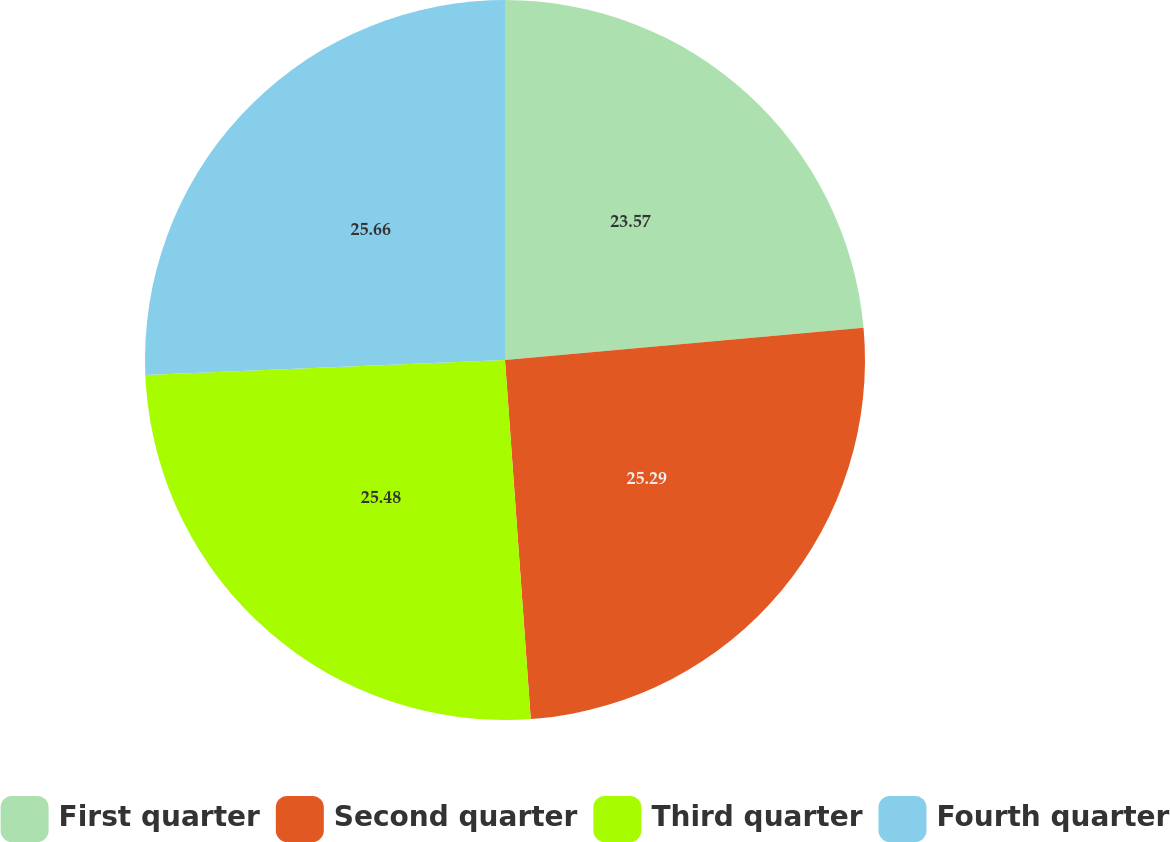Convert chart. <chart><loc_0><loc_0><loc_500><loc_500><pie_chart><fcel>First quarter<fcel>Second quarter<fcel>Third quarter<fcel>Fourth quarter<nl><fcel>23.57%<fcel>25.29%<fcel>25.48%<fcel>25.66%<nl></chart> 